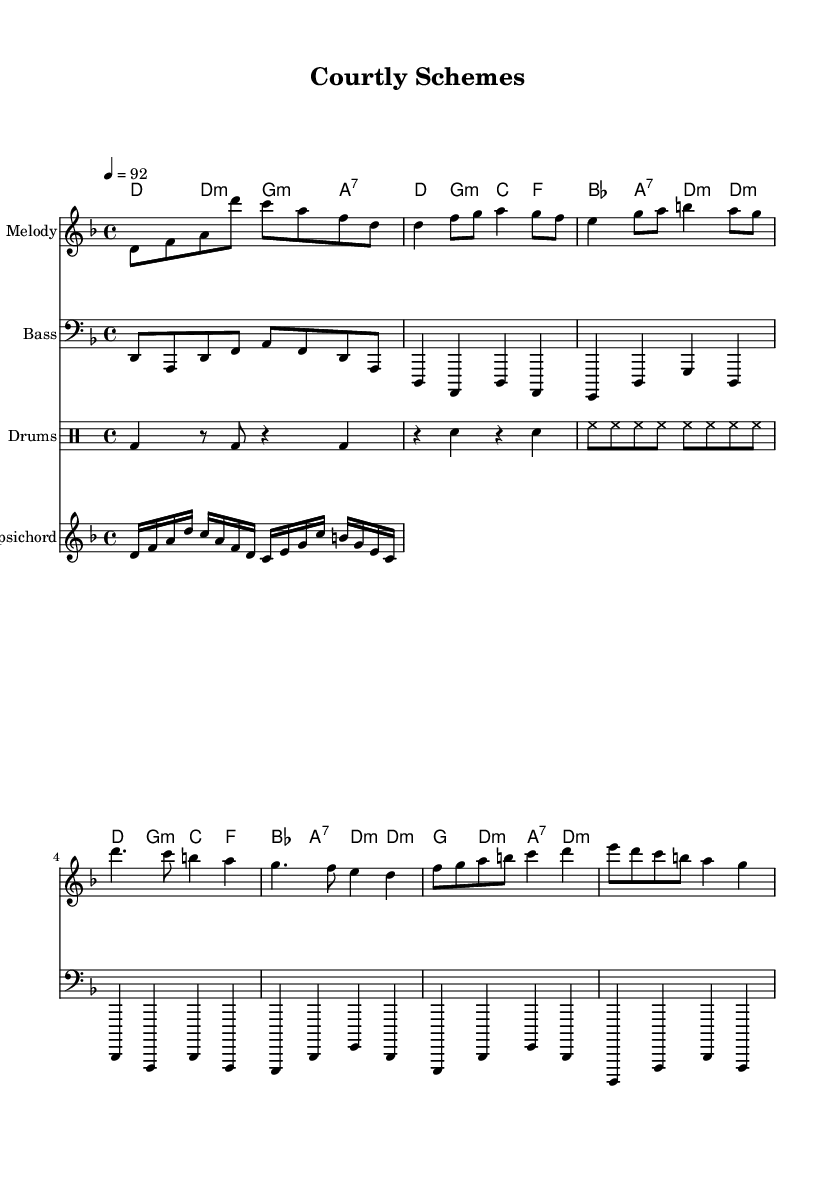What is the key signature of this music? The key signature is D minor, which has one flat (B flat). This can be determined by looking at the key signature in the beginning of the score.
Answer: D minor What is the time signature of this music? The time signature is 4/4, indicated at the beginning of the score. This means there are four beats in each measure, and the quarter note gets one beat.
Answer: 4/4 What is the tempo marking of this music? The tempo marking is 92 beats per minute, indicated above the staff. This tells the performer how fast to play the piece.
Answer: 92 How many measures are in the chorus section? The chorus section consists of two measures, which can be identified as the repeating lines of music after the verse. Each measure is demarcated clearly in the sheet music.
Answer: 2 What type of drum pattern is indicated in this score? The drum pattern includes bass drum, snare drum, and hi-hat, specified by the notation in the drum staff. This is typical for a hip-hop or rap rhythm.
Answer: Bass, snare, hi-hat What chord follows the first measure of the verse? The chord that follows the first measure of the verse is G minor. This can be found in the chord symbols placed above the melody line throughout the verse section.
Answer: G minor What is the defining characteristic of the melody in this piece? The defining characteristic of the melody is its incorporation of rhythmic and melodic elements common in rap, such as syncopation and variations in pitch. The melody is intentionally designed to reflect the lyrical flow typical in hip-hop.
Answer: Syncopation 